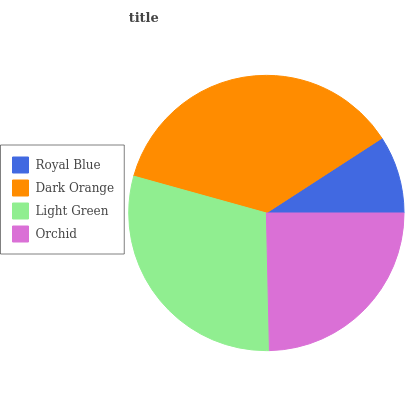Is Royal Blue the minimum?
Answer yes or no. Yes. Is Dark Orange the maximum?
Answer yes or no. Yes. Is Light Green the minimum?
Answer yes or no. No. Is Light Green the maximum?
Answer yes or no. No. Is Dark Orange greater than Light Green?
Answer yes or no. Yes. Is Light Green less than Dark Orange?
Answer yes or no. Yes. Is Light Green greater than Dark Orange?
Answer yes or no. No. Is Dark Orange less than Light Green?
Answer yes or no. No. Is Light Green the high median?
Answer yes or no. Yes. Is Orchid the low median?
Answer yes or no. Yes. Is Orchid the high median?
Answer yes or no. No. Is Royal Blue the low median?
Answer yes or no. No. 